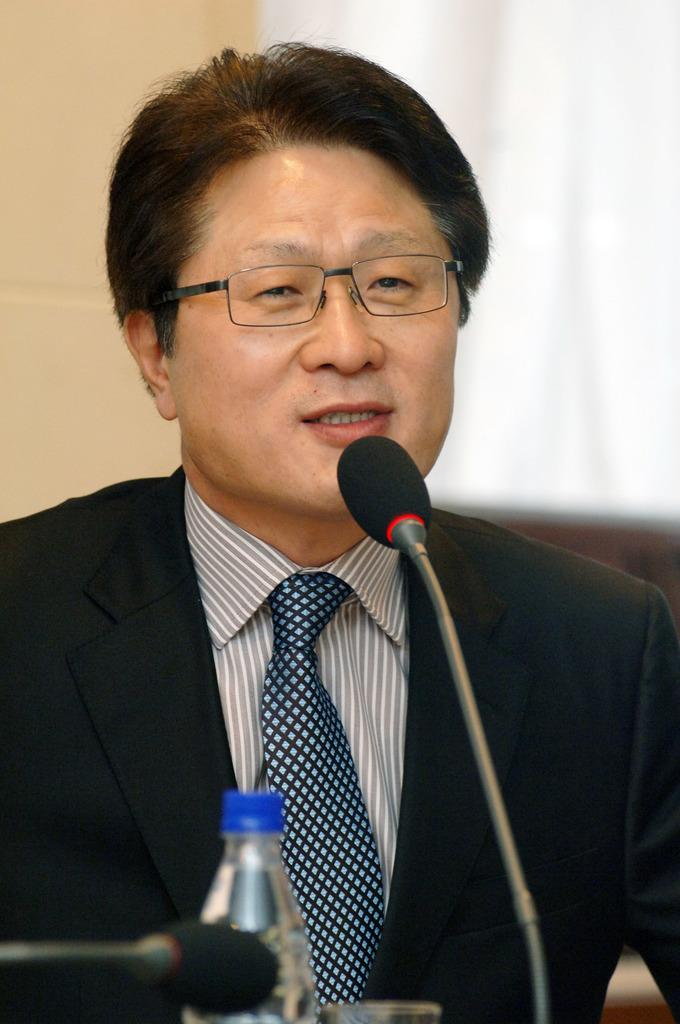Who is present in the image? There is a person in the image. What is the person wearing? The person is wearing a suit. What is the person doing in the image? The person is speaking on a microphone. Can you identify any other objects in the image? Yes, there is a water bottle in the image. What is the chance of rain during the person's speech in the image? There is no information about the weather or chance of rain in the image, as it only shows a person wearing a suit and speaking on a microphone, along with a water bottle. 